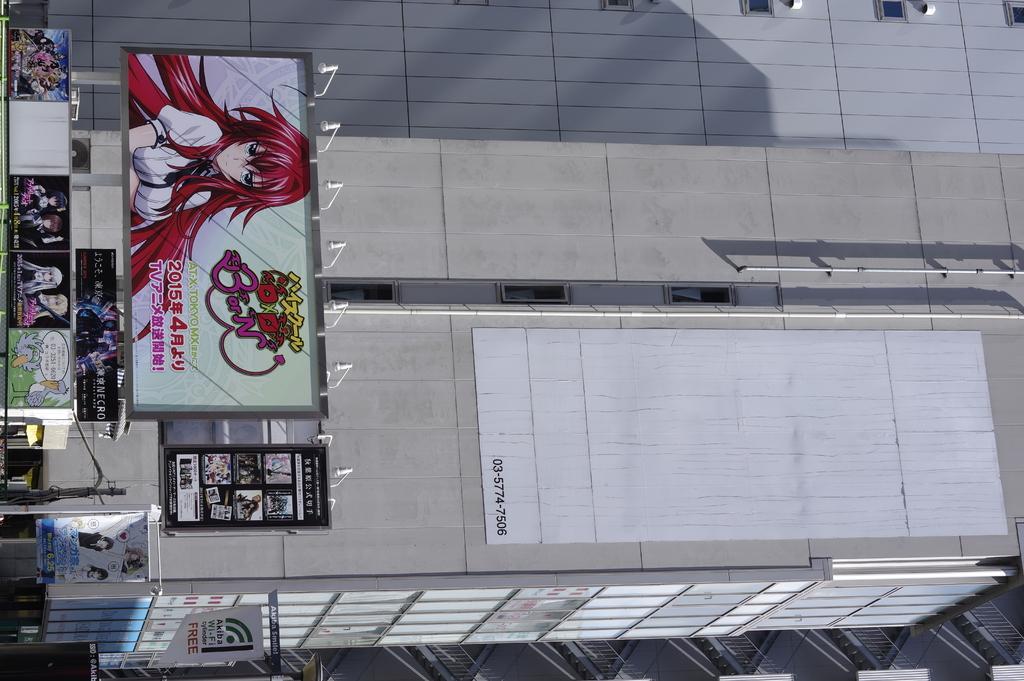Describe this image in one or two sentences. In this picture we can see posts, poles, building, railings and some objects. 